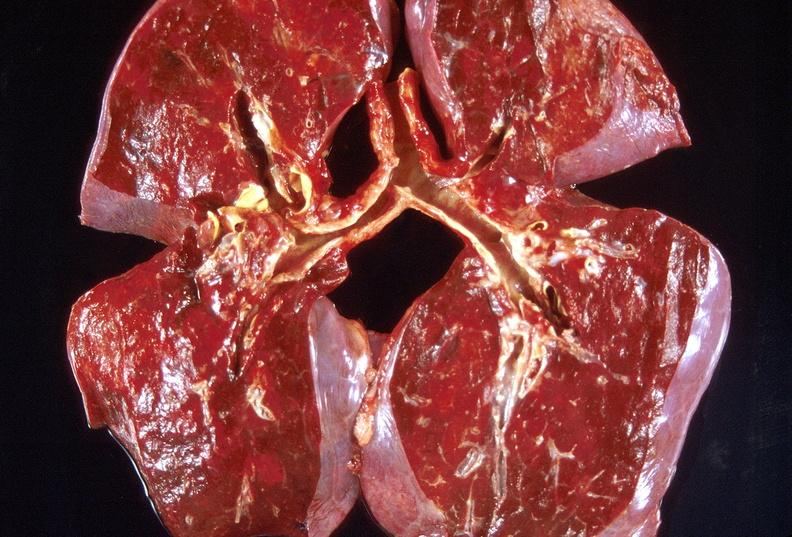what is present?
Answer the question using a single word or phrase. Respiratory 